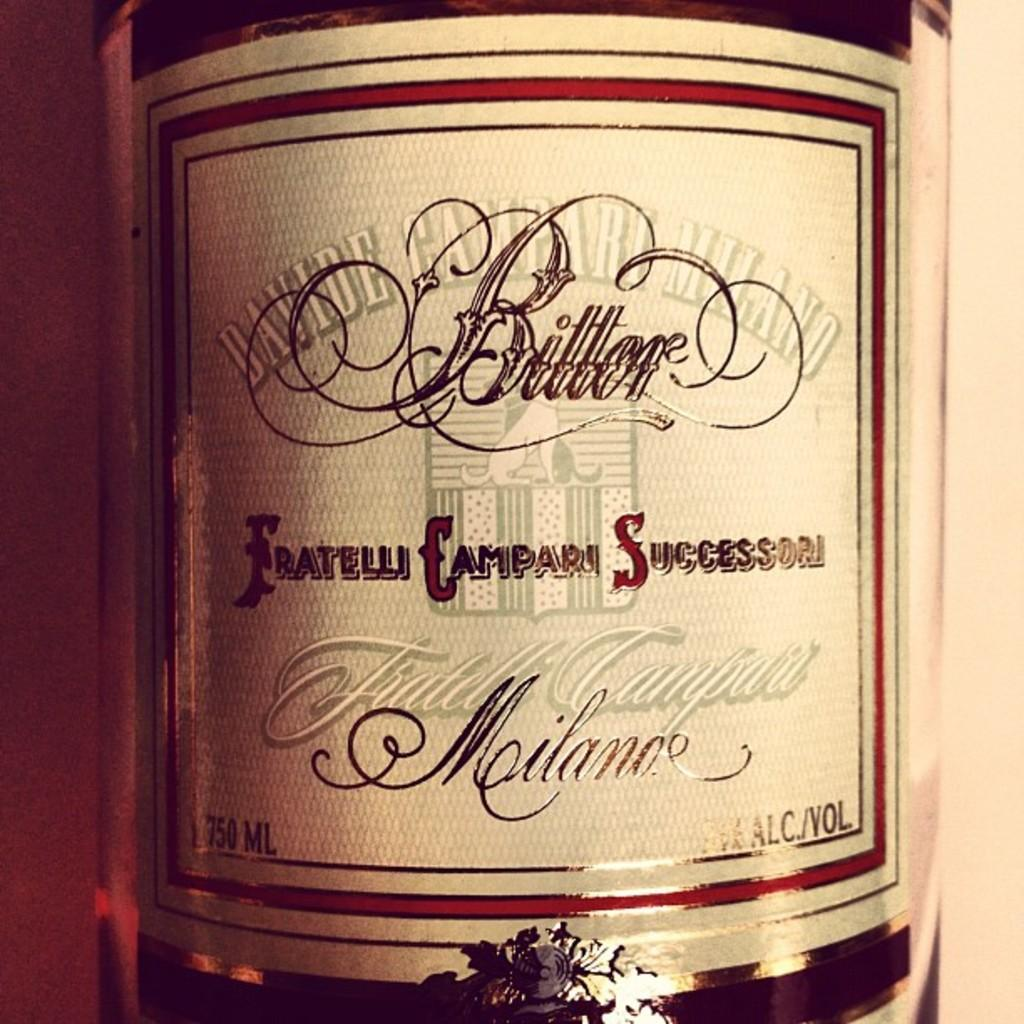<image>
Give a short and clear explanation of the subsequent image. a bottle of Bitter has a white and red label 